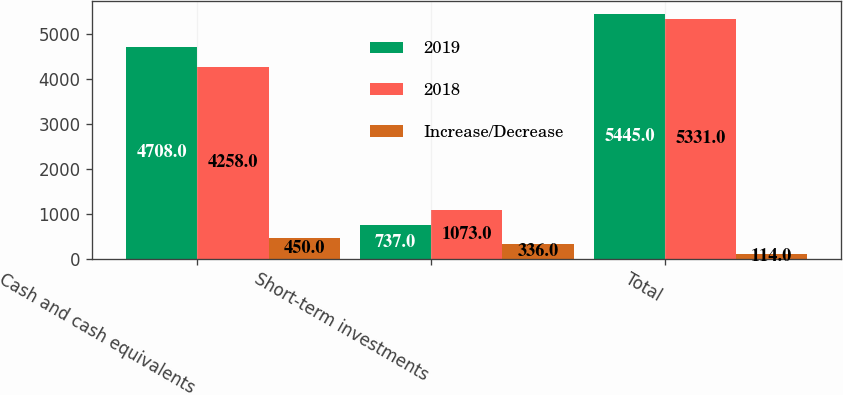Convert chart. <chart><loc_0><loc_0><loc_500><loc_500><stacked_bar_chart><ecel><fcel>Cash and cash equivalents<fcel>Short-term investments<fcel>Total<nl><fcel>2019<fcel>4708<fcel>737<fcel>5445<nl><fcel>2018<fcel>4258<fcel>1073<fcel>5331<nl><fcel>Increase/Decrease<fcel>450<fcel>336<fcel>114<nl></chart> 